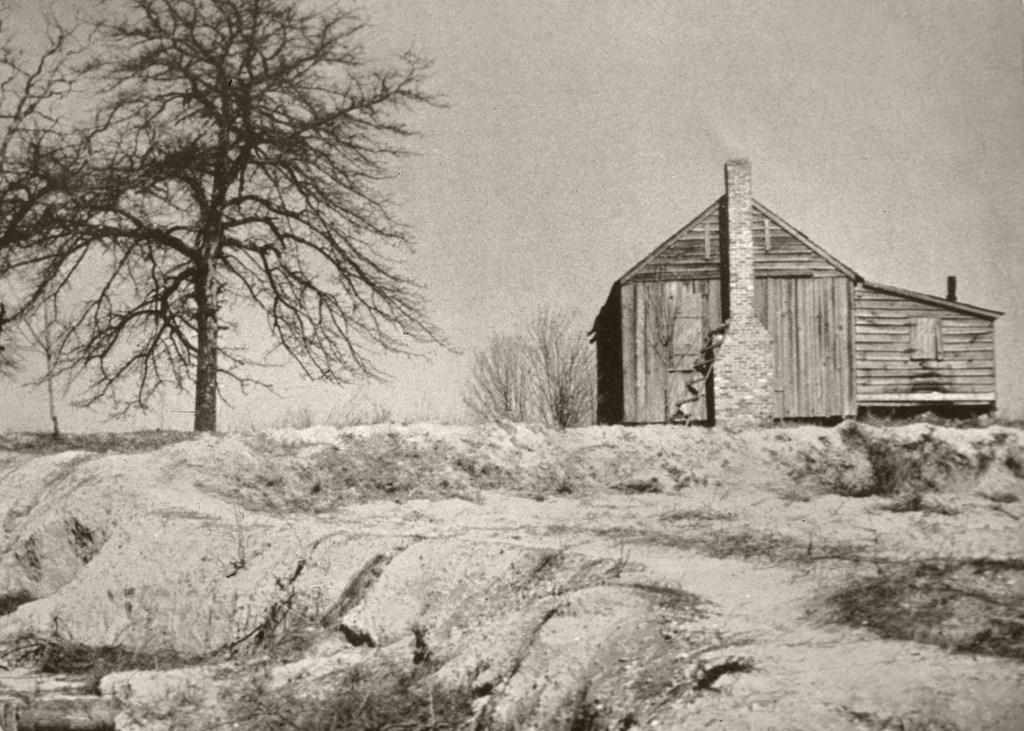What type of plant can be seen in the image? There is a tree in the image. What type of structure is located near the tree? There is a wooden house in the image, and it is beside the tree. What can be seen in the background of the image? The sky is visible in the background of the image. How many seeds can be seen on the tree in the image? There is no mention of seeds on the tree in the image, so it is not possible to determine their number. What type of needle is being used to sew the wooden house in the image? There is no indication of any sewing or needles in the image; the wooden house is already constructed. 